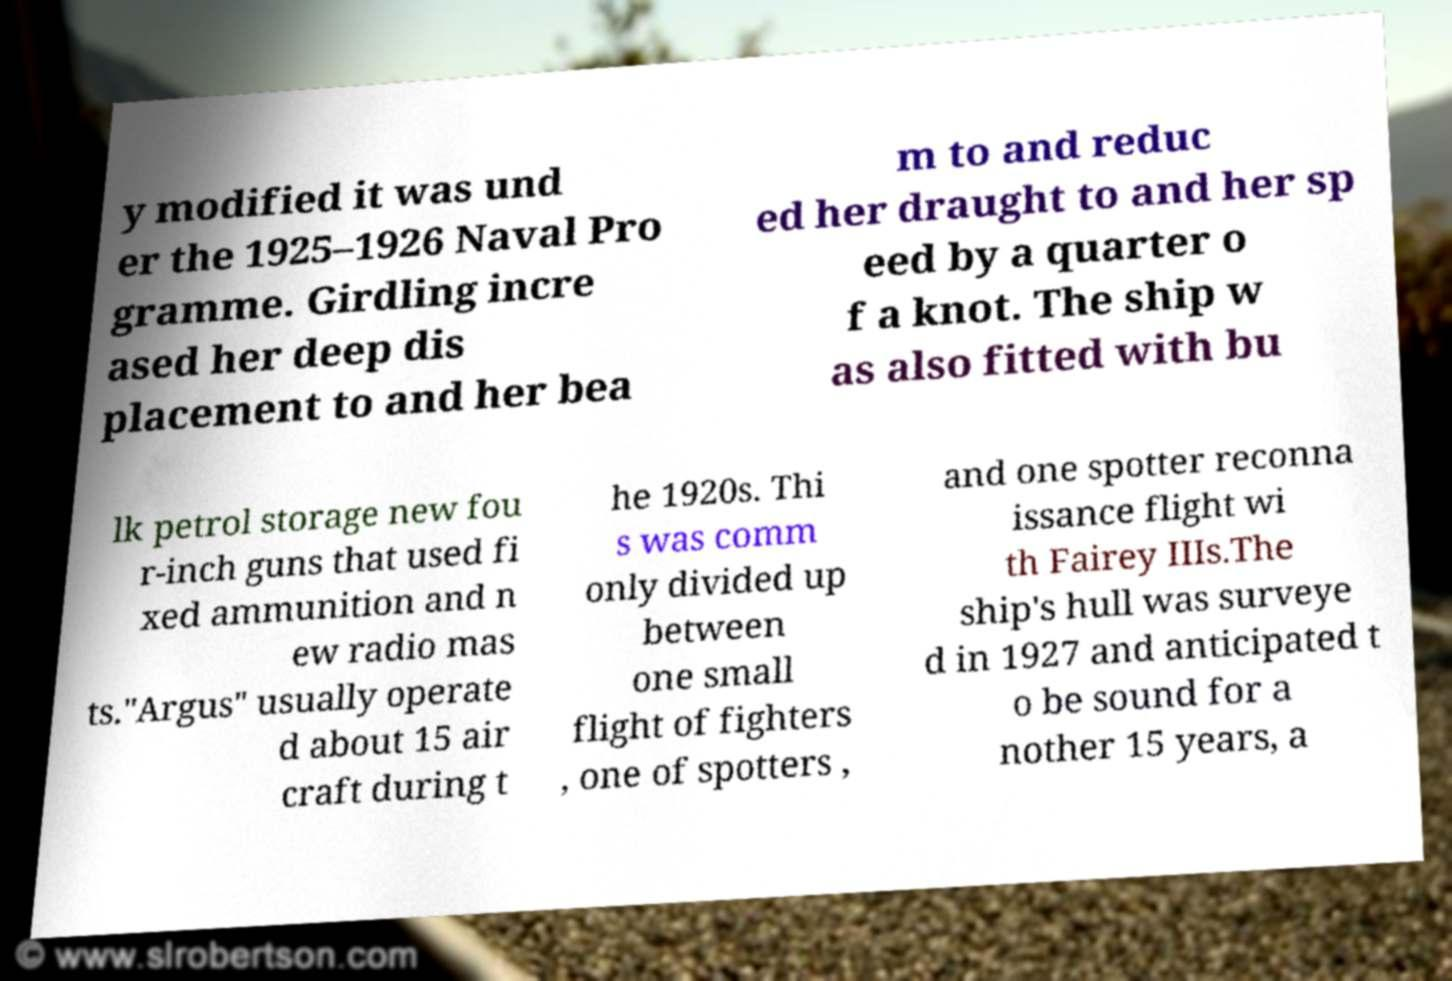What messages or text are displayed in this image? I need them in a readable, typed format. y modified it was und er the 1925–1926 Naval Pro gramme. Girdling incre ased her deep dis placement to and her bea m to and reduc ed her draught to and her sp eed by a quarter o f a knot. The ship w as also fitted with bu lk petrol storage new fou r-inch guns that used fi xed ammunition and n ew radio mas ts."Argus" usually operate d about 15 air craft during t he 1920s. Thi s was comm only divided up between one small flight of fighters , one of spotters , and one spotter reconna issance flight wi th Fairey IIIs.The ship's hull was surveye d in 1927 and anticipated t o be sound for a nother 15 years, a 